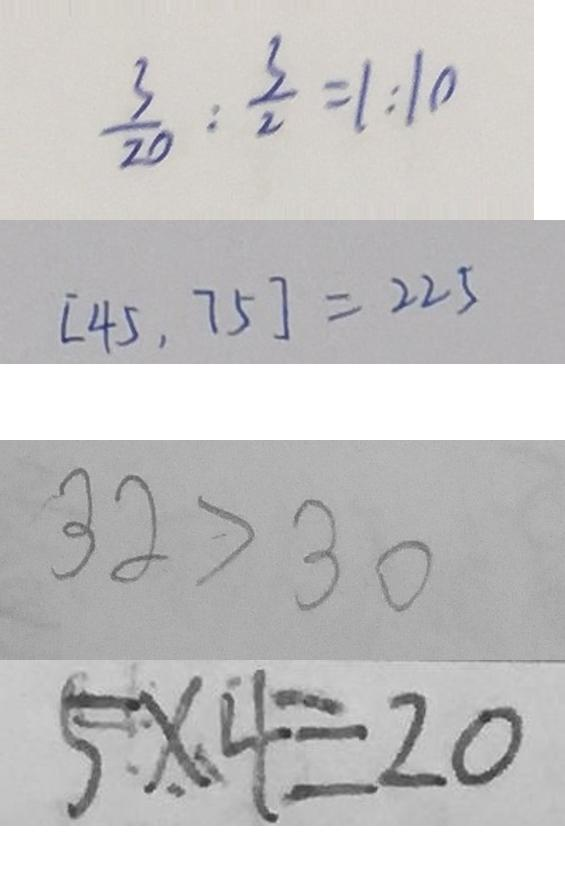Convert formula to latex. <formula><loc_0><loc_0><loc_500><loc_500>\frac { 3 } { 2 0 } : \frac { 3 } { 2 0 } = 1 : 1 0 
 [ 4 5 , 7 5 ] = 2 2 5 
 3 2 > 3 0 
 5 \times 4 = 2 0</formula> 